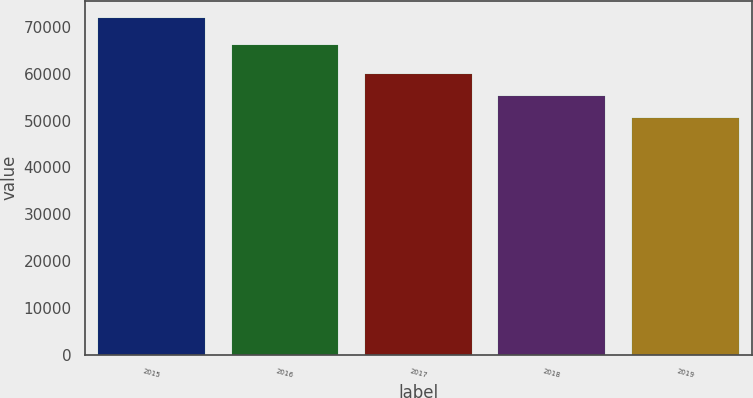Convert chart to OTSL. <chart><loc_0><loc_0><loc_500><loc_500><bar_chart><fcel>2015<fcel>2016<fcel>2017<fcel>2018<fcel>2019<nl><fcel>71966<fcel>66211<fcel>59924<fcel>55173<fcel>50631<nl></chart> 